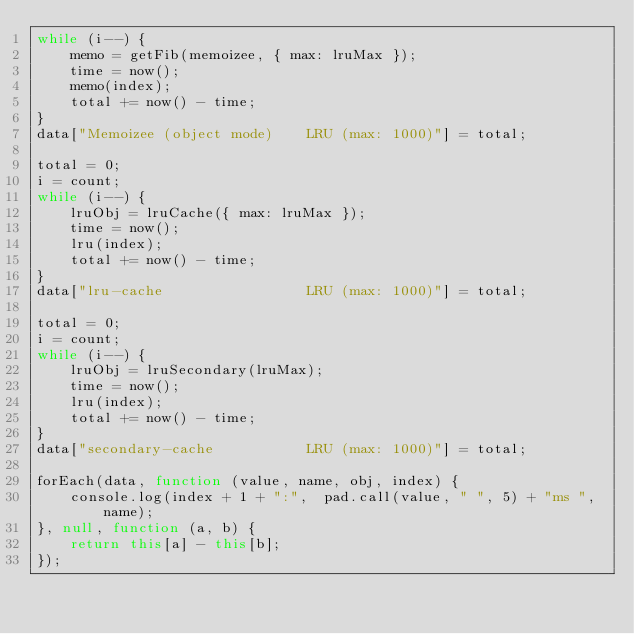<code> <loc_0><loc_0><loc_500><loc_500><_JavaScript_>while (i--) {
	memo = getFib(memoizee, { max: lruMax });
	time = now();
	memo(index);
	total += now() - time;
}
data["Memoizee (object mode)    LRU (max: 1000)"] = total;

total = 0;
i = count;
while (i--) {
	lruObj = lruCache({ max: lruMax });
	time = now();
	lru(index);
	total += now() - time;
}
data["lru-cache                 LRU (max: 1000)"] = total;

total = 0;
i = count;
while (i--) {
	lruObj = lruSecondary(lruMax);
	time = now();
	lru(index);
	total += now() - time;
}
data["secondary-cache           LRU (max: 1000)"] = total;

forEach(data, function (value, name, obj, index) {
	console.log(index + 1 + ":",  pad.call(value, " ", 5) + "ms ", name);
}, null, function (a, b) {
	return this[a] - this[b];
});
</code> 